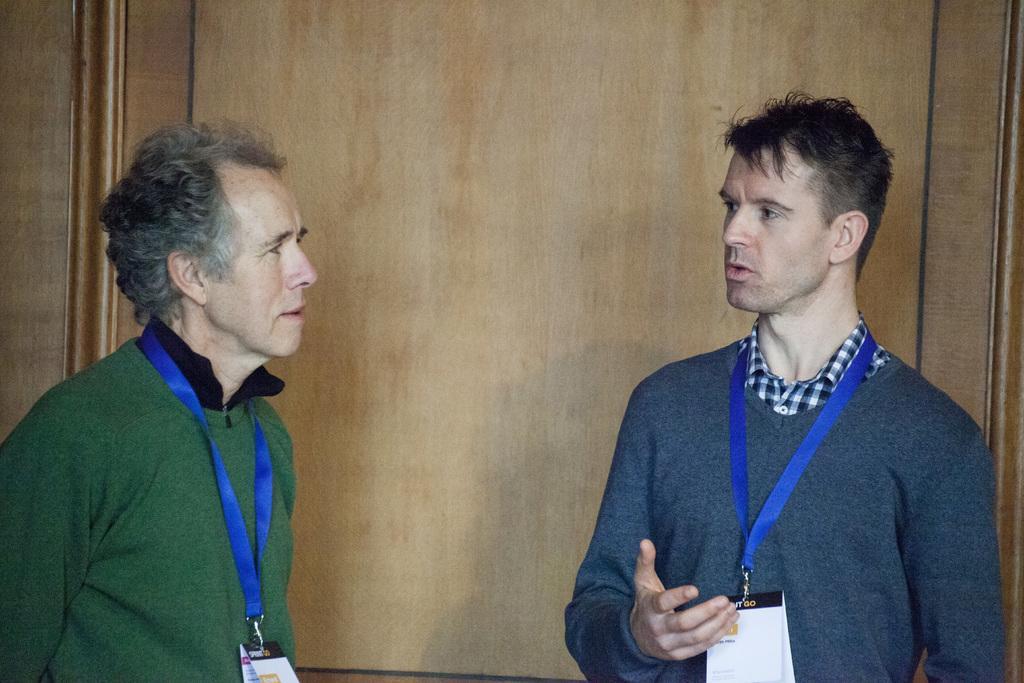Please provide a concise description of this image. In this image there are two men in the middle. In the background there is a wooden wall. On the left side there is a man who is wearing an id card. On the right side there is another man who is wearing an id card and raising his hand. 